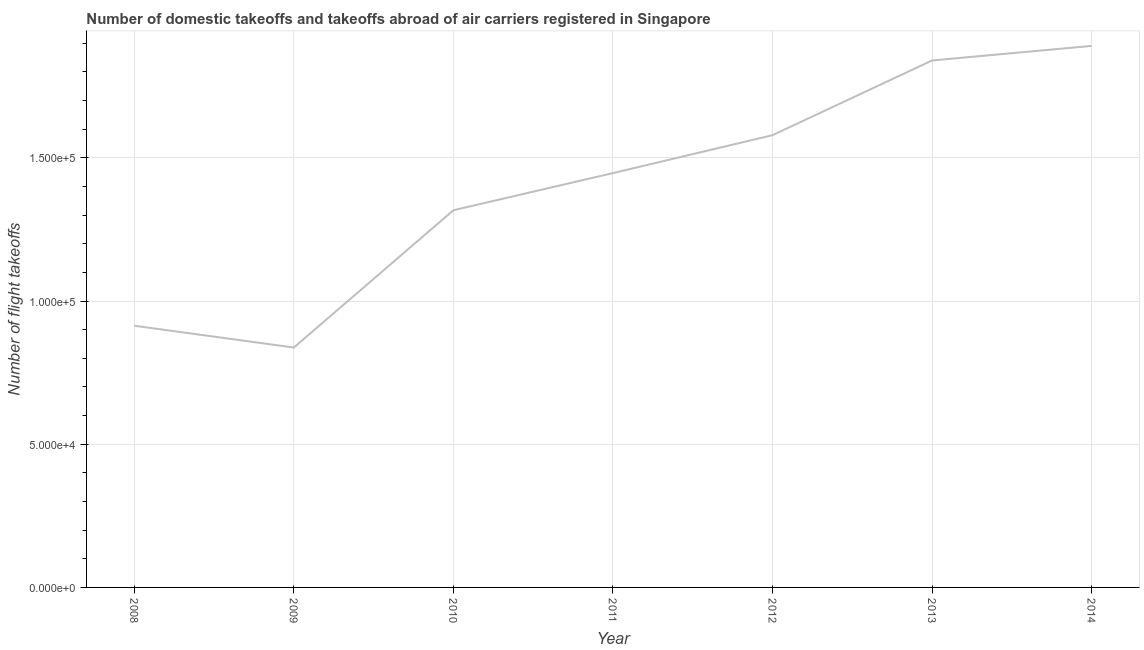What is the number of flight takeoffs in 2008?
Your answer should be compact. 9.14e+04. Across all years, what is the maximum number of flight takeoffs?
Provide a succinct answer. 1.89e+05. Across all years, what is the minimum number of flight takeoffs?
Offer a terse response. 8.38e+04. In which year was the number of flight takeoffs maximum?
Provide a short and direct response. 2014. What is the sum of the number of flight takeoffs?
Your answer should be compact. 9.83e+05. What is the difference between the number of flight takeoffs in 2010 and 2014?
Your answer should be compact. -5.74e+04. What is the average number of flight takeoffs per year?
Keep it short and to the point. 1.40e+05. What is the median number of flight takeoffs?
Offer a terse response. 1.45e+05. In how many years, is the number of flight takeoffs greater than 130000 ?
Make the answer very short. 5. What is the ratio of the number of flight takeoffs in 2011 to that in 2012?
Make the answer very short. 0.92. Is the number of flight takeoffs in 2011 less than that in 2012?
Your response must be concise. Yes. Is the difference between the number of flight takeoffs in 2008 and 2010 greater than the difference between any two years?
Give a very brief answer. No. What is the difference between the highest and the second highest number of flight takeoffs?
Your answer should be compact. 5085.81. Is the sum of the number of flight takeoffs in 2010 and 2013 greater than the maximum number of flight takeoffs across all years?
Provide a short and direct response. Yes. What is the difference between the highest and the lowest number of flight takeoffs?
Ensure brevity in your answer.  1.05e+05. In how many years, is the number of flight takeoffs greater than the average number of flight takeoffs taken over all years?
Your response must be concise. 4. How many lines are there?
Give a very brief answer. 1. How many years are there in the graph?
Ensure brevity in your answer.  7. Are the values on the major ticks of Y-axis written in scientific E-notation?
Provide a succinct answer. Yes. Does the graph contain any zero values?
Provide a short and direct response. No. What is the title of the graph?
Ensure brevity in your answer.  Number of domestic takeoffs and takeoffs abroad of air carriers registered in Singapore. What is the label or title of the X-axis?
Your answer should be very brief. Year. What is the label or title of the Y-axis?
Give a very brief answer. Number of flight takeoffs. What is the Number of flight takeoffs in 2008?
Offer a very short reply. 9.14e+04. What is the Number of flight takeoffs of 2009?
Give a very brief answer. 8.38e+04. What is the Number of flight takeoffs in 2010?
Provide a short and direct response. 1.32e+05. What is the Number of flight takeoffs in 2011?
Make the answer very short. 1.45e+05. What is the Number of flight takeoffs in 2012?
Keep it short and to the point. 1.58e+05. What is the Number of flight takeoffs in 2013?
Keep it short and to the point. 1.84e+05. What is the Number of flight takeoffs of 2014?
Your answer should be very brief. 1.89e+05. What is the difference between the Number of flight takeoffs in 2008 and 2009?
Offer a terse response. 7615. What is the difference between the Number of flight takeoffs in 2008 and 2010?
Ensure brevity in your answer.  -4.03e+04. What is the difference between the Number of flight takeoffs in 2008 and 2011?
Offer a terse response. -5.33e+04. What is the difference between the Number of flight takeoffs in 2008 and 2012?
Offer a terse response. -6.66e+04. What is the difference between the Number of flight takeoffs in 2008 and 2013?
Provide a short and direct response. -9.26e+04. What is the difference between the Number of flight takeoffs in 2008 and 2014?
Give a very brief answer. -9.77e+04. What is the difference between the Number of flight takeoffs in 2009 and 2010?
Offer a terse response. -4.79e+04. What is the difference between the Number of flight takeoffs in 2009 and 2011?
Provide a short and direct response. -6.09e+04. What is the difference between the Number of flight takeoffs in 2009 and 2012?
Provide a short and direct response. -7.42e+04. What is the difference between the Number of flight takeoffs in 2009 and 2013?
Provide a succinct answer. -1.00e+05. What is the difference between the Number of flight takeoffs in 2009 and 2014?
Offer a terse response. -1.05e+05. What is the difference between the Number of flight takeoffs in 2010 and 2011?
Give a very brief answer. -1.30e+04. What is the difference between the Number of flight takeoffs in 2010 and 2012?
Your answer should be very brief. -2.62e+04. What is the difference between the Number of flight takeoffs in 2010 and 2013?
Offer a terse response. -5.23e+04. What is the difference between the Number of flight takeoffs in 2010 and 2014?
Make the answer very short. -5.74e+04. What is the difference between the Number of flight takeoffs in 2011 and 2012?
Offer a terse response. -1.32e+04. What is the difference between the Number of flight takeoffs in 2011 and 2013?
Keep it short and to the point. -3.93e+04. What is the difference between the Number of flight takeoffs in 2011 and 2014?
Make the answer very short. -4.44e+04. What is the difference between the Number of flight takeoffs in 2012 and 2013?
Provide a short and direct response. -2.61e+04. What is the difference between the Number of flight takeoffs in 2012 and 2014?
Ensure brevity in your answer.  -3.12e+04. What is the difference between the Number of flight takeoffs in 2013 and 2014?
Keep it short and to the point. -5085.81. What is the ratio of the Number of flight takeoffs in 2008 to that in 2009?
Provide a succinct answer. 1.09. What is the ratio of the Number of flight takeoffs in 2008 to that in 2010?
Ensure brevity in your answer.  0.69. What is the ratio of the Number of flight takeoffs in 2008 to that in 2011?
Your answer should be compact. 0.63. What is the ratio of the Number of flight takeoffs in 2008 to that in 2012?
Give a very brief answer. 0.58. What is the ratio of the Number of flight takeoffs in 2008 to that in 2013?
Offer a very short reply. 0.5. What is the ratio of the Number of flight takeoffs in 2008 to that in 2014?
Make the answer very short. 0.48. What is the ratio of the Number of flight takeoffs in 2009 to that in 2010?
Provide a short and direct response. 0.64. What is the ratio of the Number of flight takeoffs in 2009 to that in 2011?
Your answer should be compact. 0.58. What is the ratio of the Number of flight takeoffs in 2009 to that in 2012?
Your answer should be compact. 0.53. What is the ratio of the Number of flight takeoffs in 2009 to that in 2013?
Provide a short and direct response. 0.46. What is the ratio of the Number of flight takeoffs in 2009 to that in 2014?
Provide a succinct answer. 0.44. What is the ratio of the Number of flight takeoffs in 2010 to that in 2011?
Your answer should be very brief. 0.91. What is the ratio of the Number of flight takeoffs in 2010 to that in 2012?
Your answer should be compact. 0.83. What is the ratio of the Number of flight takeoffs in 2010 to that in 2013?
Your answer should be very brief. 0.72. What is the ratio of the Number of flight takeoffs in 2010 to that in 2014?
Your response must be concise. 0.7. What is the ratio of the Number of flight takeoffs in 2011 to that in 2012?
Your response must be concise. 0.92. What is the ratio of the Number of flight takeoffs in 2011 to that in 2013?
Provide a short and direct response. 0.79. What is the ratio of the Number of flight takeoffs in 2011 to that in 2014?
Provide a succinct answer. 0.77. What is the ratio of the Number of flight takeoffs in 2012 to that in 2013?
Offer a very short reply. 0.86. What is the ratio of the Number of flight takeoffs in 2012 to that in 2014?
Keep it short and to the point. 0.83. What is the ratio of the Number of flight takeoffs in 2013 to that in 2014?
Keep it short and to the point. 0.97. 